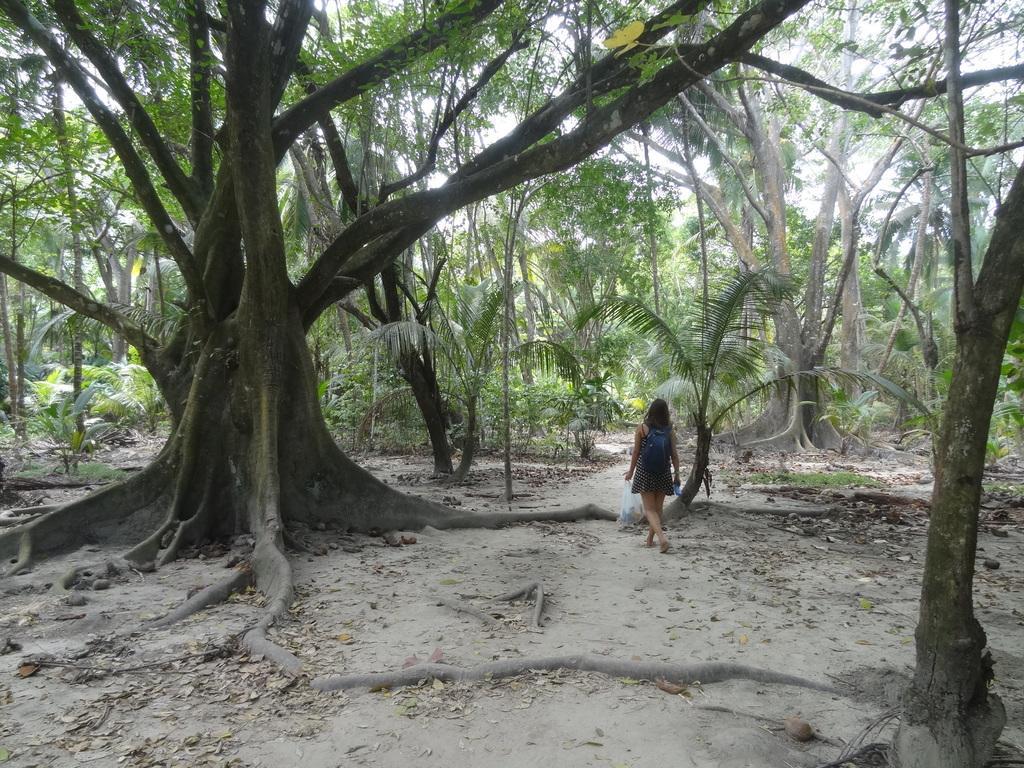Can you describe this image briefly? This image consists of a woman wearing a backpack is walking. At the bottom, there are dried leaves on the ground. It looks like a forest. In the front, there are many trees. 